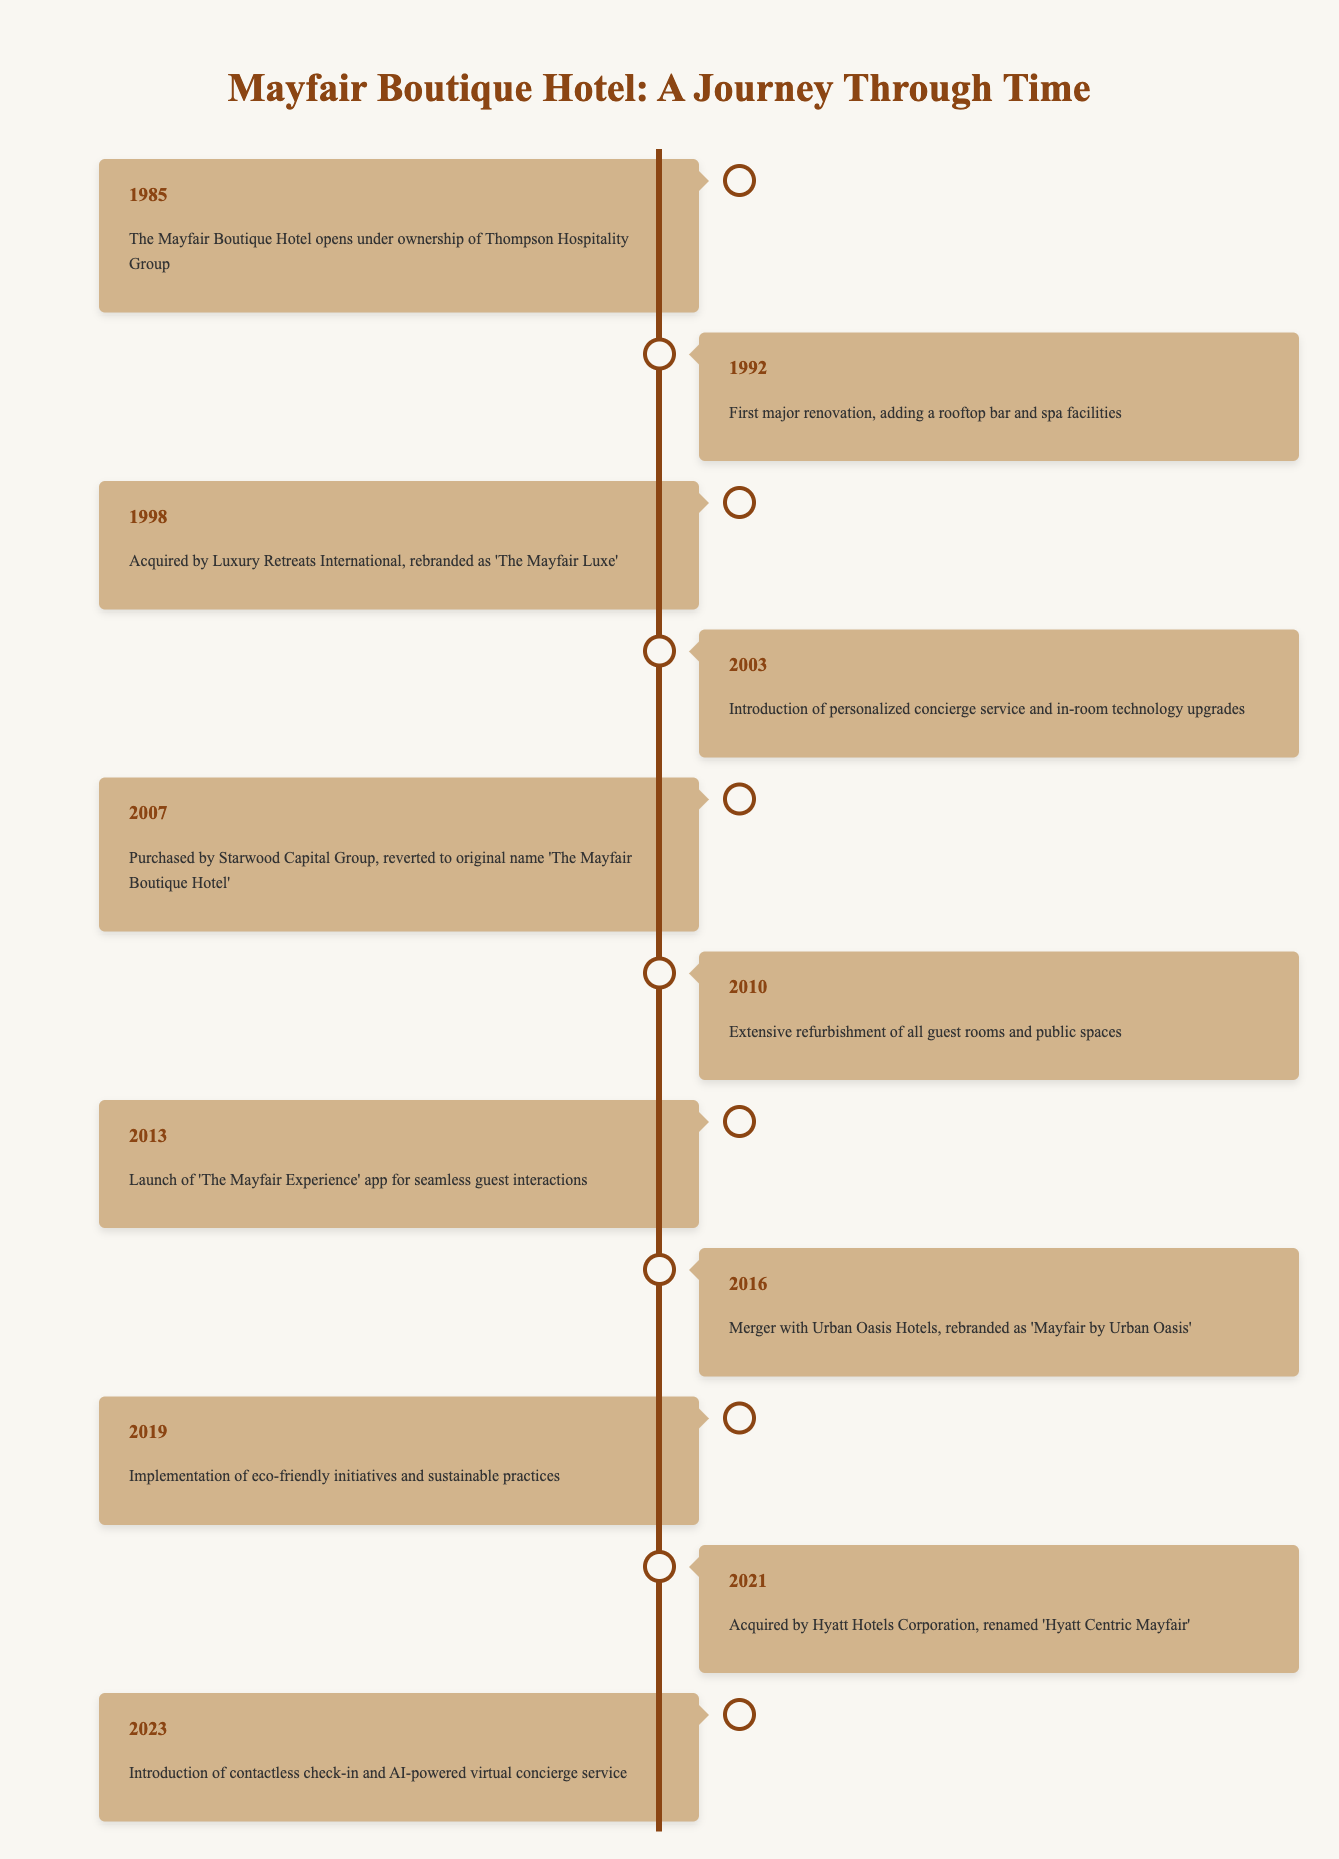What year did 'The Mayfair Luxe' rebranding occur? The event in the timeline indicates that 'The Mayfair Luxe' was the name change after the hotel was acquired by Luxury Retreats International in 1998.
Answer: 1998 What major renovation happened in 1992? According to the timeline, the first major renovation of the hotel included the addition of a rooftop bar and spa facilities.
Answer: Adding a rooftop bar and spa facilities Which event introduced sustainable practices at the hotel? The timeline states that the implementation of eco-friendly initiatives and sustainable practices occurred in 2019.
Answer: 2019 Was there a rebranding after Hyatt Hotels Corporation acquired the hotel? The timeline mentions that after Hyatt Hotels Corporation acquired the hotel in 2021, it was renamed 'Hyatt Centric Mayfair,' confirming the rebranding.
Answer: Yes How many times did the hotel change its name from 1985 to 2023? From the timeline, the hotel changed its name three times: it first opened as 'The Mayfair Boutique Hotel,' changed to 'The Mayfair Luxe,' and then became 'Mayfair by Urban Oasis,' followed by 'Hyatt Centric Mayfair.' Thus, the total is three name changes.
Answer: Three times What years saw renovations or refurbishments? By reviewing the timeline, renovations occurred in 1992 (major renovation) and 2010 (extensive refurbishment), leading to two instances of renovations or refurbishments mentioned in the events.
Answer: 1992 and 2010 What were the names the hotel was known by between 1985 and 2023? The timeline lists the following names: 'The Mayfair Boutique Hotel' (1985, 2007), 'The Mayfair Luxe' (1998), 'Mayfair by Urban Oasis' (2016), and 'Hyatt Centric Mayfair' (2021). Thus, the hotel had four names during this period.
Answer: Four names What significant technological update was introduced in 2013? The timeline shows that in 2013, 'The Mayfair Experience' app was launched to facilitate seamless guest interactions, indicating a significant technological update.
Answer: Launch of 'The Mayfair Experience' app When was the personalized concierge service introduced? According to the timeline, the personalized concierge service was introduced in 2003, making it the year of this significant enhancement to the guest experience.
Answer: 2003 